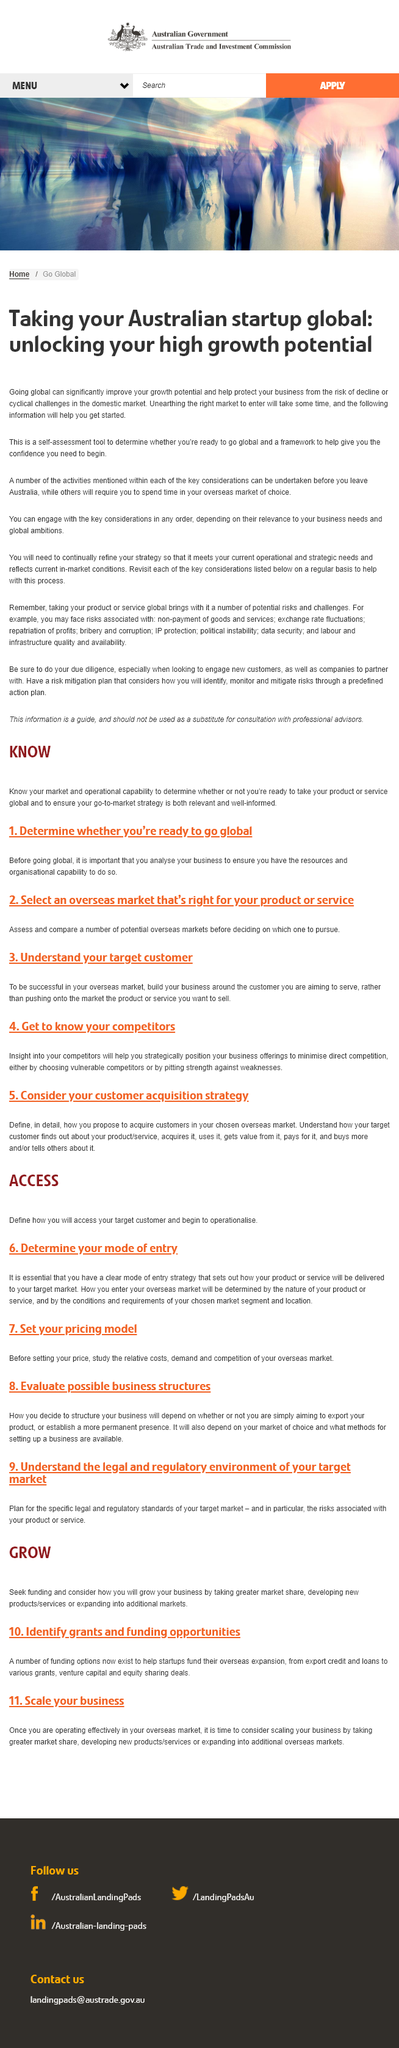Highlight a few significant elements in this photo. Going global is a key strategy for improving a business and mitigating the risk of decline in the domestic market. By expanding into new markets, businesses can increase their growth potential and protect themselves from the risk of decline in their home market. No, not all of the activities can be done within Australia. Some require spending time in the overseas market of the company's choice. Locating the optimal market in Australia will not be an easy task, as it will require significant effort and time to uncover the right audience. 